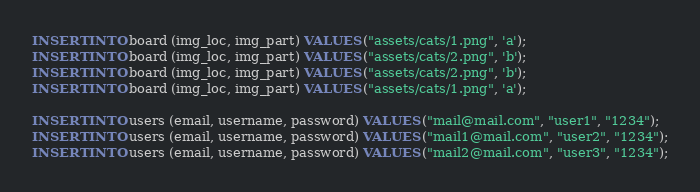Convert code to text. <code><loc_0><loc_0><loc_500><loc_500><_SQL_>INSERT INTO board (img_loc, img_part) VALUES ("assets/cats/1.png", 'a');
INSERT INTO board (img_loc, img_part) VALUES ("assets/cats/2.png", 'b');
INSERT INTO board (img_loc, img_part) VALUES ("assets/cats/2.png", 'b');
INSERT INTO board (img_loc, img_part) VALUES ("assets/cats/1.png", 'a');

INSERT INTO users (email, username, password) VALUES ("mail@mail.com", "user1", "1234");
INSERT INTO users (email, username, password) VALUES ("mail1@mail.com", "user2", "1234");
INSERT INTO users (email, username, password) VALUES ("mail2@mail.com", "user3", "1234");</code> 